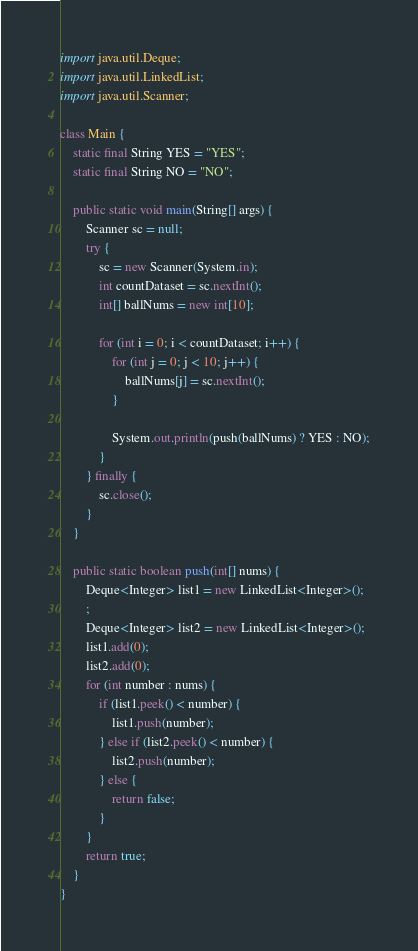Convert code to text. <code><loc_0><loc_0><loc_500><loc_500><_Java_>import java.util.Deque;
import java.util.LinkedList;
import java.util.Scanner;

class Main {
	static final String YES = "YES";
	static final String NO = "NO";

	public static void main(String[] args) {
		Scanner sc = null;
		try {
			sc = new Scanner(System.in);
			int countDataset = sc.nextInt();
			int[] ballNums = new int[10];

			for (int i = 0; i < countDataset; i++) {
				for (int j = 0; j < 10; j++) {
					ballNums[j] = sc.nextInt();
				}

				System.out.println(push(ballNums) ? YES : NO);
			}
		} finally {
			sc.close();
		}
	}

	public static boolean push(int[] nums) {
		Deque<Integer> list1 = new LinkedList<Integer>();
		;
		Deque<Integer> list2 = new LinkedList<Integer>();
		list1.add(0);
		list2.add(0);
		for (int number : nums) {
			if (list1.peek() < number) {
				list1.push(number);
			} else if (list2.peek() < number) {
				list2.push(number);
			} else {
				return false;
			}
		}
		return true;
	}
}</code> 